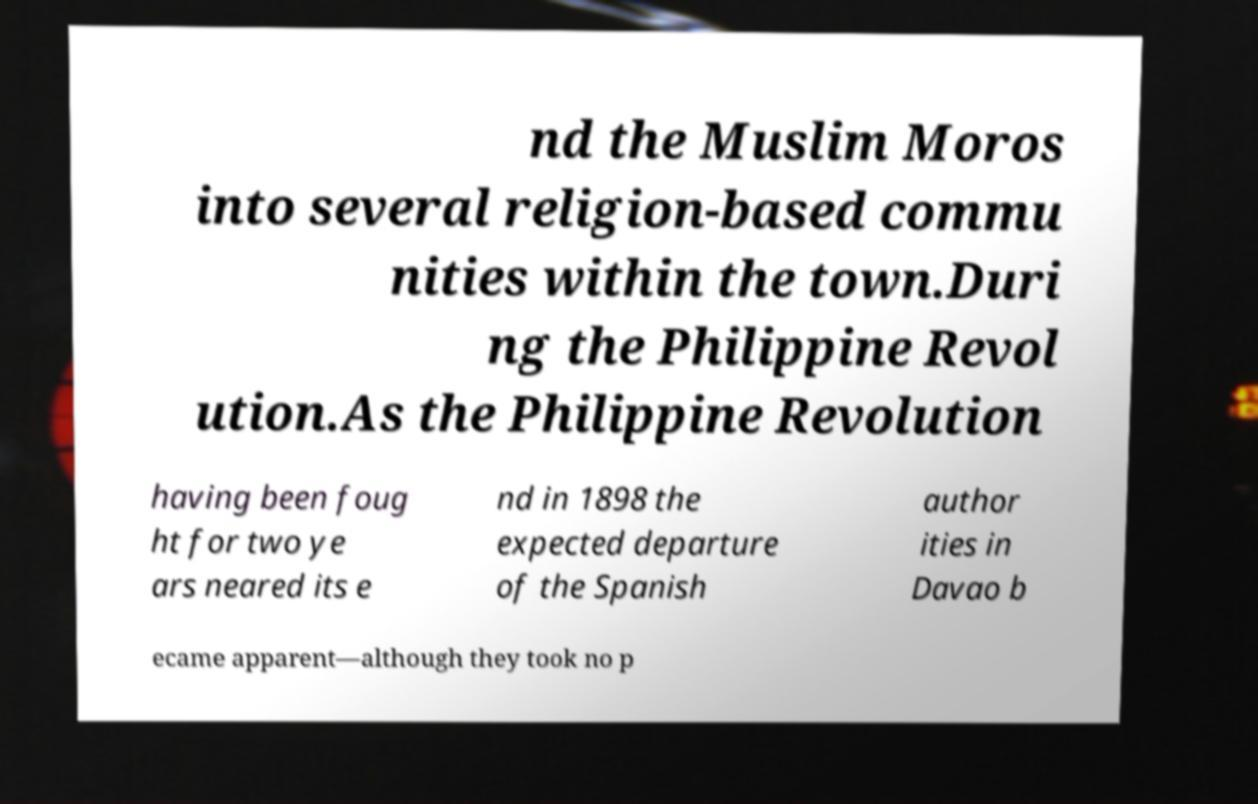Can you read and provide the text displayed in the image?This photo seems to have some interesting text. Can you extract and type it out for me? nd the Muslim Moros into several religion-based commu nities within the town.Duri ng the Philippine Revol ution.As the Philippine Revolution having been foug ht for two ye ars neared its e nd in 1898 the expected departure of the Spanish author ities in Davao b ecame apparent—although they took no p 